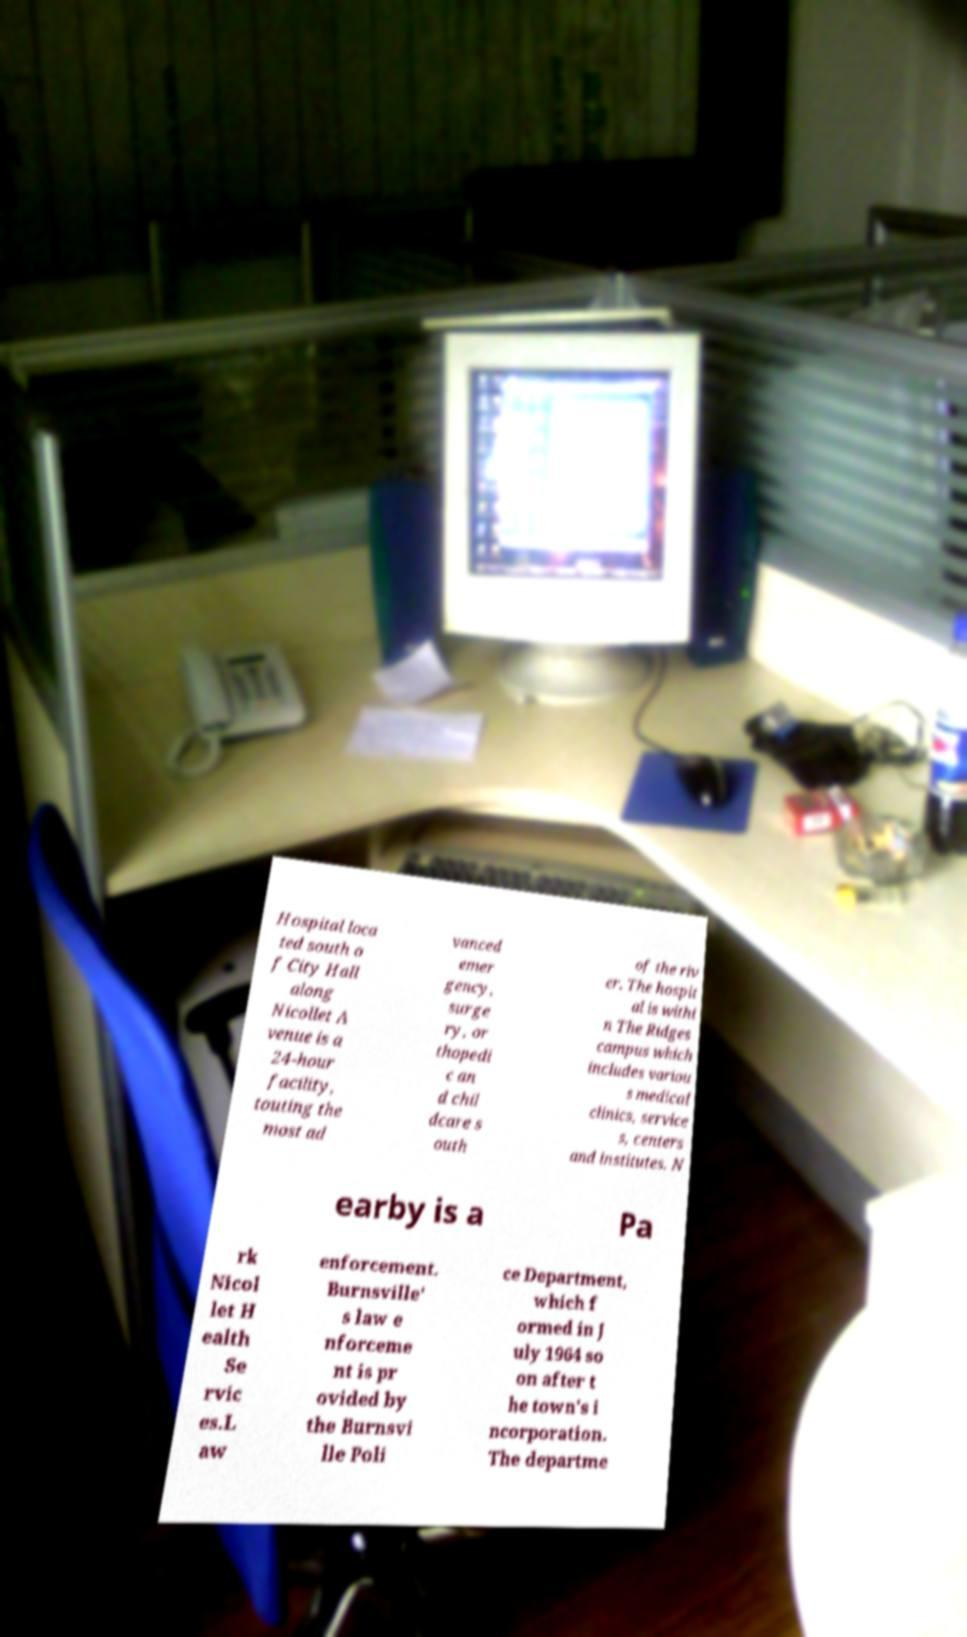Can you read and provide the text displayed in the image?This photo seems to have some interesting text. Can you extract and type it out for me? Hospital loca ted south o f City Hall along Nicollet A venue is a 24-hour facility, touting the most ad vanced emer gency, surge ry, or thopedi c an d chil dcare s outh of the riv er. The hospit al is withi n The Ridges campus which includes variou s medical clinics, service s, centers and institutes. N earby is a Pa rk Nicol let H ealth Se rvic es.L aw enforcement. Burnsville' s law e nforceme nt is pr ovided by the Burnsvi lle Poli ce Department, which f ormed in J uly 1964 so on after t he town's i ncorporation. The departme 